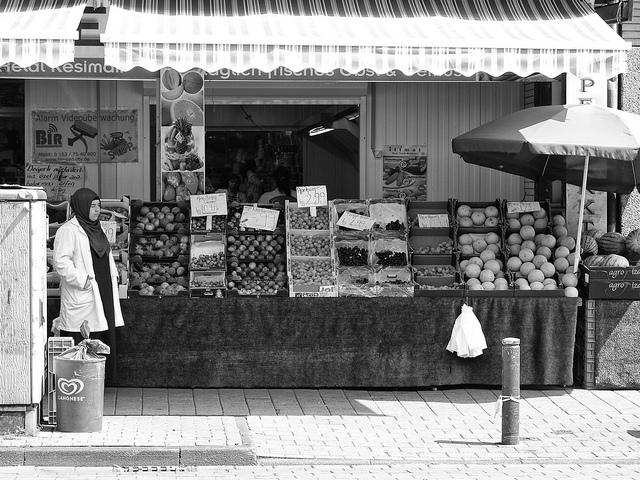The largest fruit shown here is what type of Fruit?

Choices:
A) cherry
B) citrus
C) pome
D) melon melon 